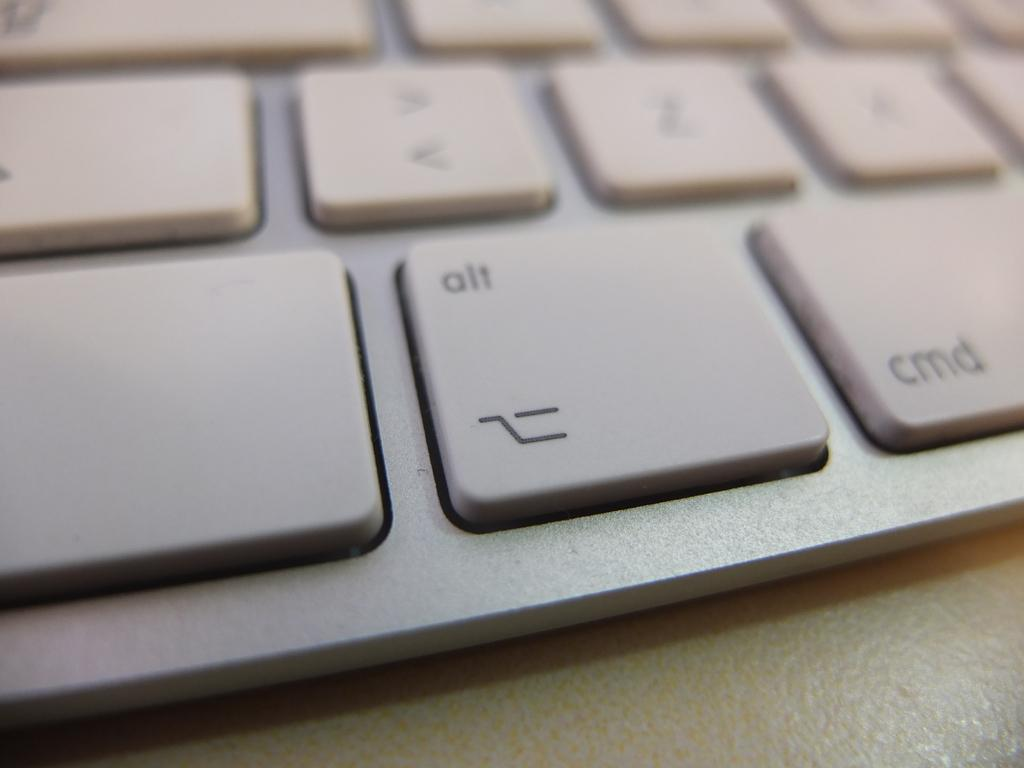What is the main object in the image? There is a keyboard in the image. What can be found on the keys of the keyboard? The keyboard has text and symbols. How does the dirt affect the functionality of the keyboard in the image? There is no dirt present in the image, so it cannot affect the functionality of the keyboard. 